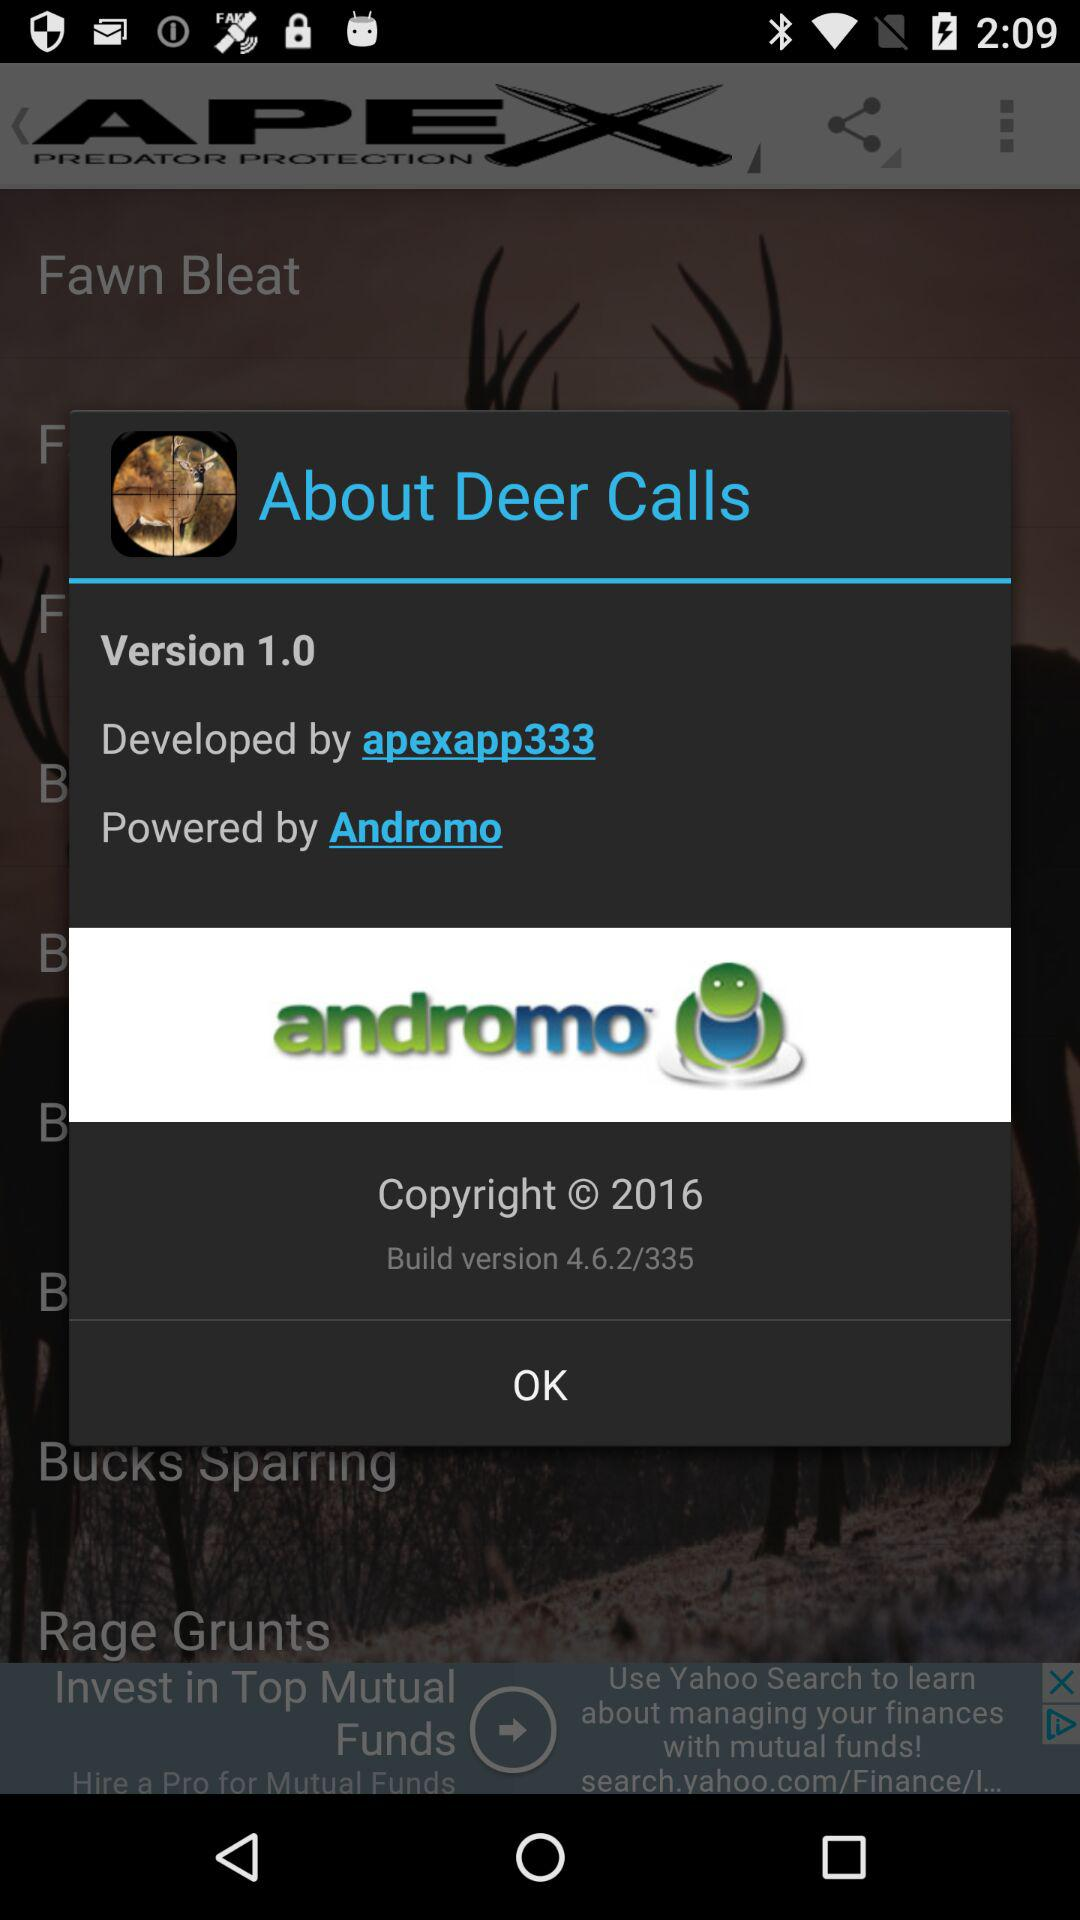What is the build number of the app?
Answer the question using a single word or phrase. 4.6.2/335 